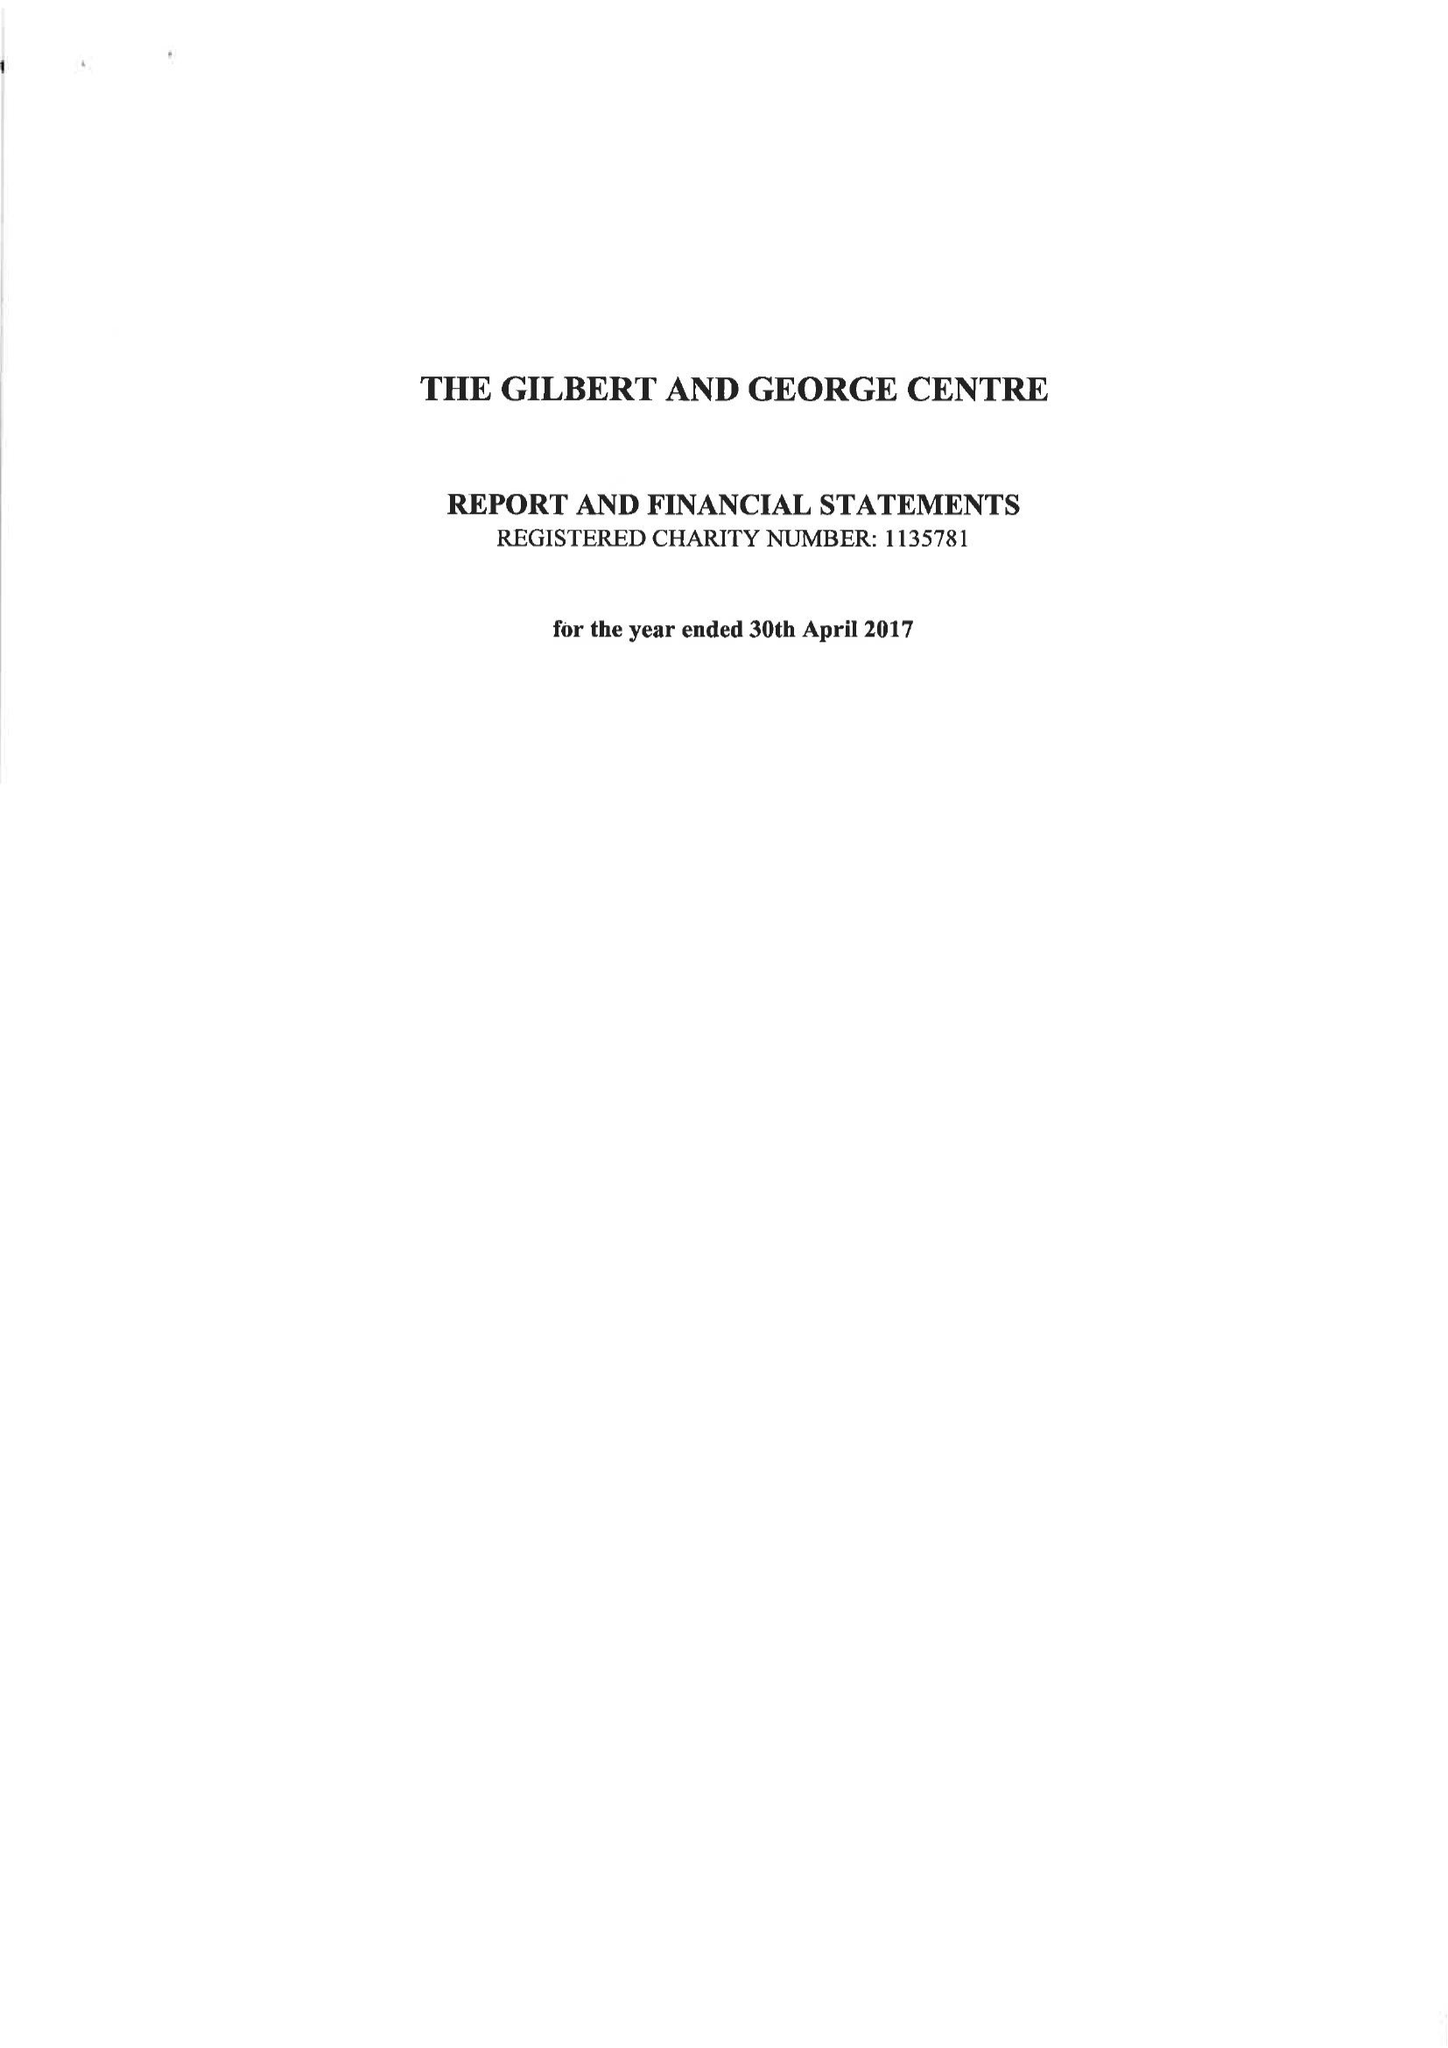What is the value for the report_date?
Answer the question using a single word or phrase. 2017-04-30 